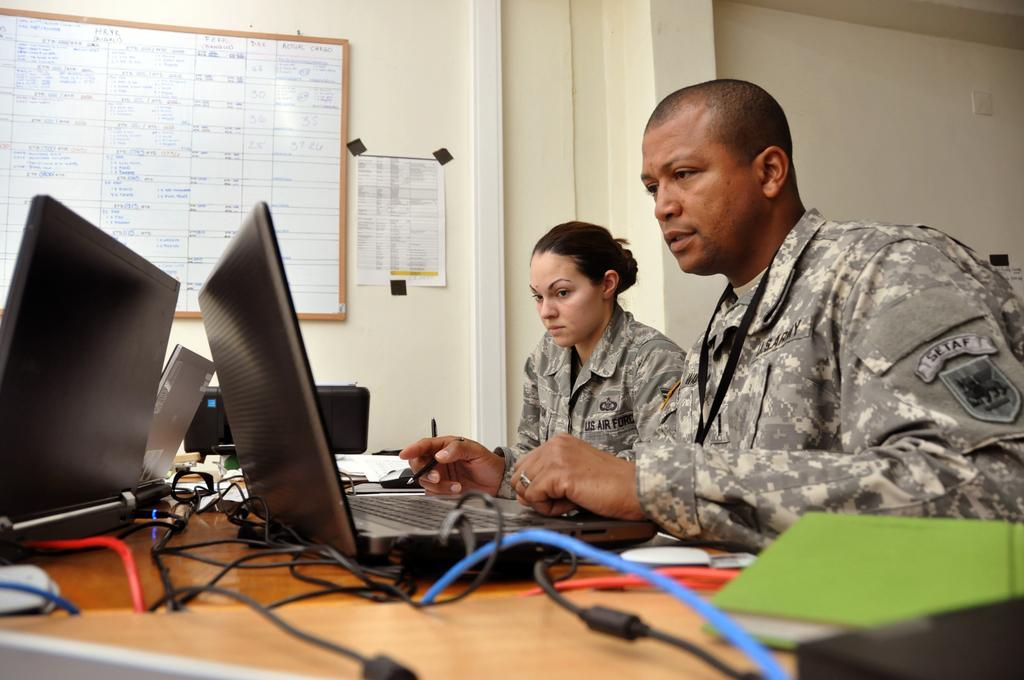<image>
Offer a succinct explanation of the picture presented. Two person in the military, one is in the US Air Force, are working with computers. 